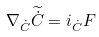<formula> <loc_0><loc_0><loc_500><loc_500>\nabla _ { \dot { C } } \widetilde { \dot { C } } = i _ { \dot { C } } F</formula> 